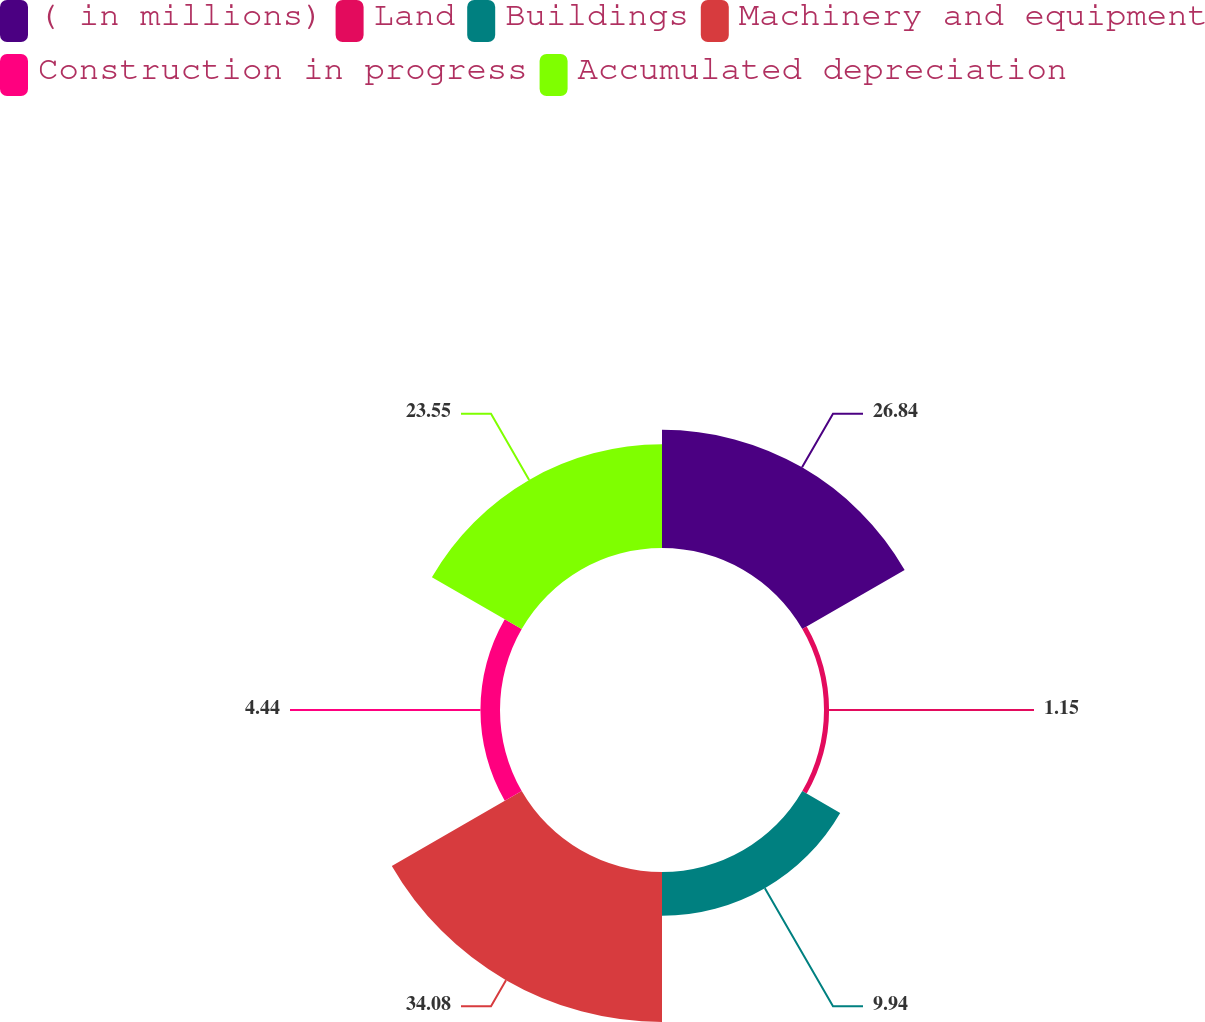Convert chart to OTSL. <chart><loc_0><loc_0><loc_500><loc_500><pie_chart><fcel>( in millions)<fcel>Land<fcel>Buildings<fcel>Machinery and equipment<fcel>Construction in progress<fcel>Accumulated depreciation<nl><fcel>26.84%<fcel>1.15%<fcel>9.94%<fcel>34.07%<fcel>4.44%<fcel>23.55%<nl></chart> 